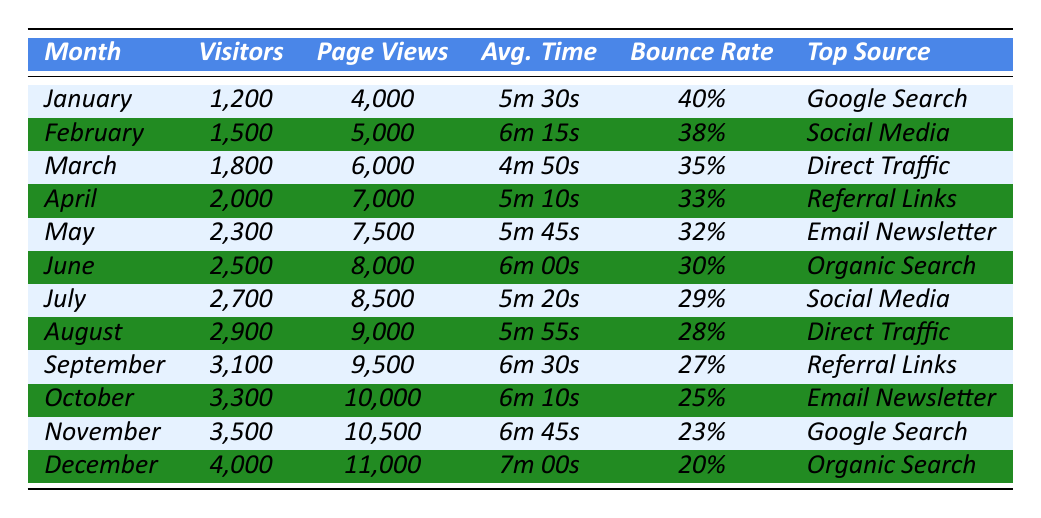What was the top source of traffic in July? In the table, the month of July shows that the top source of traffic was delineated under the "Top Source" column. From the data, it is indicated that for July, the source was "Social Media."
Answer: Social Media How many visitors did the blog receive in March? Looking at the row for March in the table, the "Visitors" column shows that the blog received 1,800 visitors during that month.
Answer: 1,800 What was the average bounce rate for the months of January and February? The bounce rates for January and February are 40% and 38% respectively. To find the average, we sum them (40% + 38% = 78%) and then divide by 2, resulting in an average of 39%.
Answer: 39% Which month had the highest number of page views? By scanning the "Page Views" column, we see that December shows the highest figure at 11,000 page views, more than any other month.
Answer: December Did the average time on site increase or decrease from June to July? Comparing the "Average Time on Site" for June (6m 00s) and July (5m 20s), we see that June had a longer duration. Thus, the average time on site decreased from June to July.
Answer: Decreased What is the total number of visitors from June to December? We add the total number of visitors from June (2,500) to December (4,000) and all months in between (2,700 + 2,900 + 3,100 + 3,300 + 3,500). This amounts to: 2,500 + 2,700 + 2,900 + 3,100 + 3,300 + 3,500 + 4,000 = 22,000 visitors.
Answer: 22,000 How many more page views did December have compared to January? In January, the page views were 4,000, while in December they were 11,000. The difference is 11,000 - 4,000 = 7,000 more page views in December than in January.
Answer: 7,000 Was there a month in which the bounce rate was lower than 30%? By reviewing the "Bounce Rate" column, we find that both June (30%) and lower rates follow in July (29%), August (28%), September (27%), and so forth. Therefore, yes, multiple months had a bounce rate below 30%.
Answer: Yes Which month recorded the highest average time on site? Looking through the "Average Time on Site" column, December has the highest value at 7m 00s, compared to other months.
Answer: December What was the average number of visitors across the year? To find the average, we sum all the visitors from January (1,200) to December (4,000) and divide by 12 (the total months). This results in: (1,200 + 1,500 + 1,800 + 2,000 + 2,300 + 2,500 + 2,700 + 2,900 + 3,100 + 3,300 + 3,500 + 4,000) / 12 = 2,575 visitors on average.
Answer: 2,575 Which source generated the most traffic in the first half of the year? The first half of the year consists of January to June. Looking at the "Top Source" column, the top sources are "Google Search" (January), "Social Media" (February), "Direct Traffic" (March), "Referral Links" (April), "Email Newsletter" (May), and "Organic Search" (June). The most recurring sources are "Social Media" and "Google Search." However, "Google Search" appears only once, indicating "Social Media" to also be significant from this data set.
Answer: Social Media 